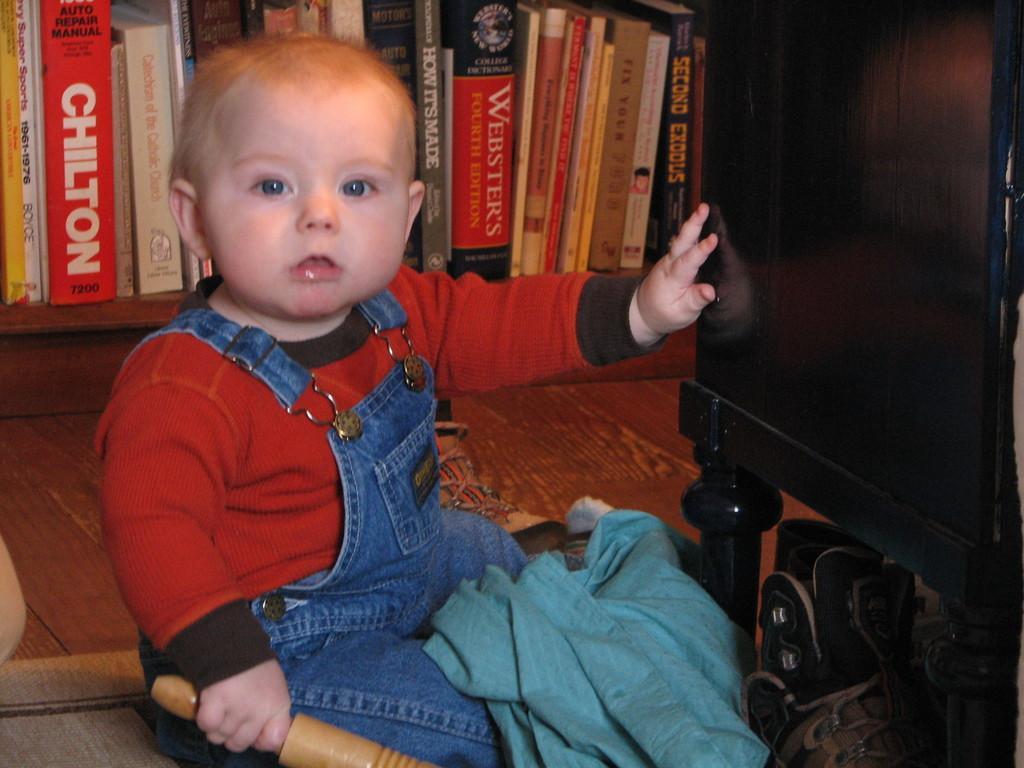Could you give a brief overview of what you see in this image? In this picture I can see a child sitting in front and I see that the child is holding a thing. In the background I can see number of books. On the right side of this picture I can see a brown color thing and near to it, I can see a blue color cloth. 